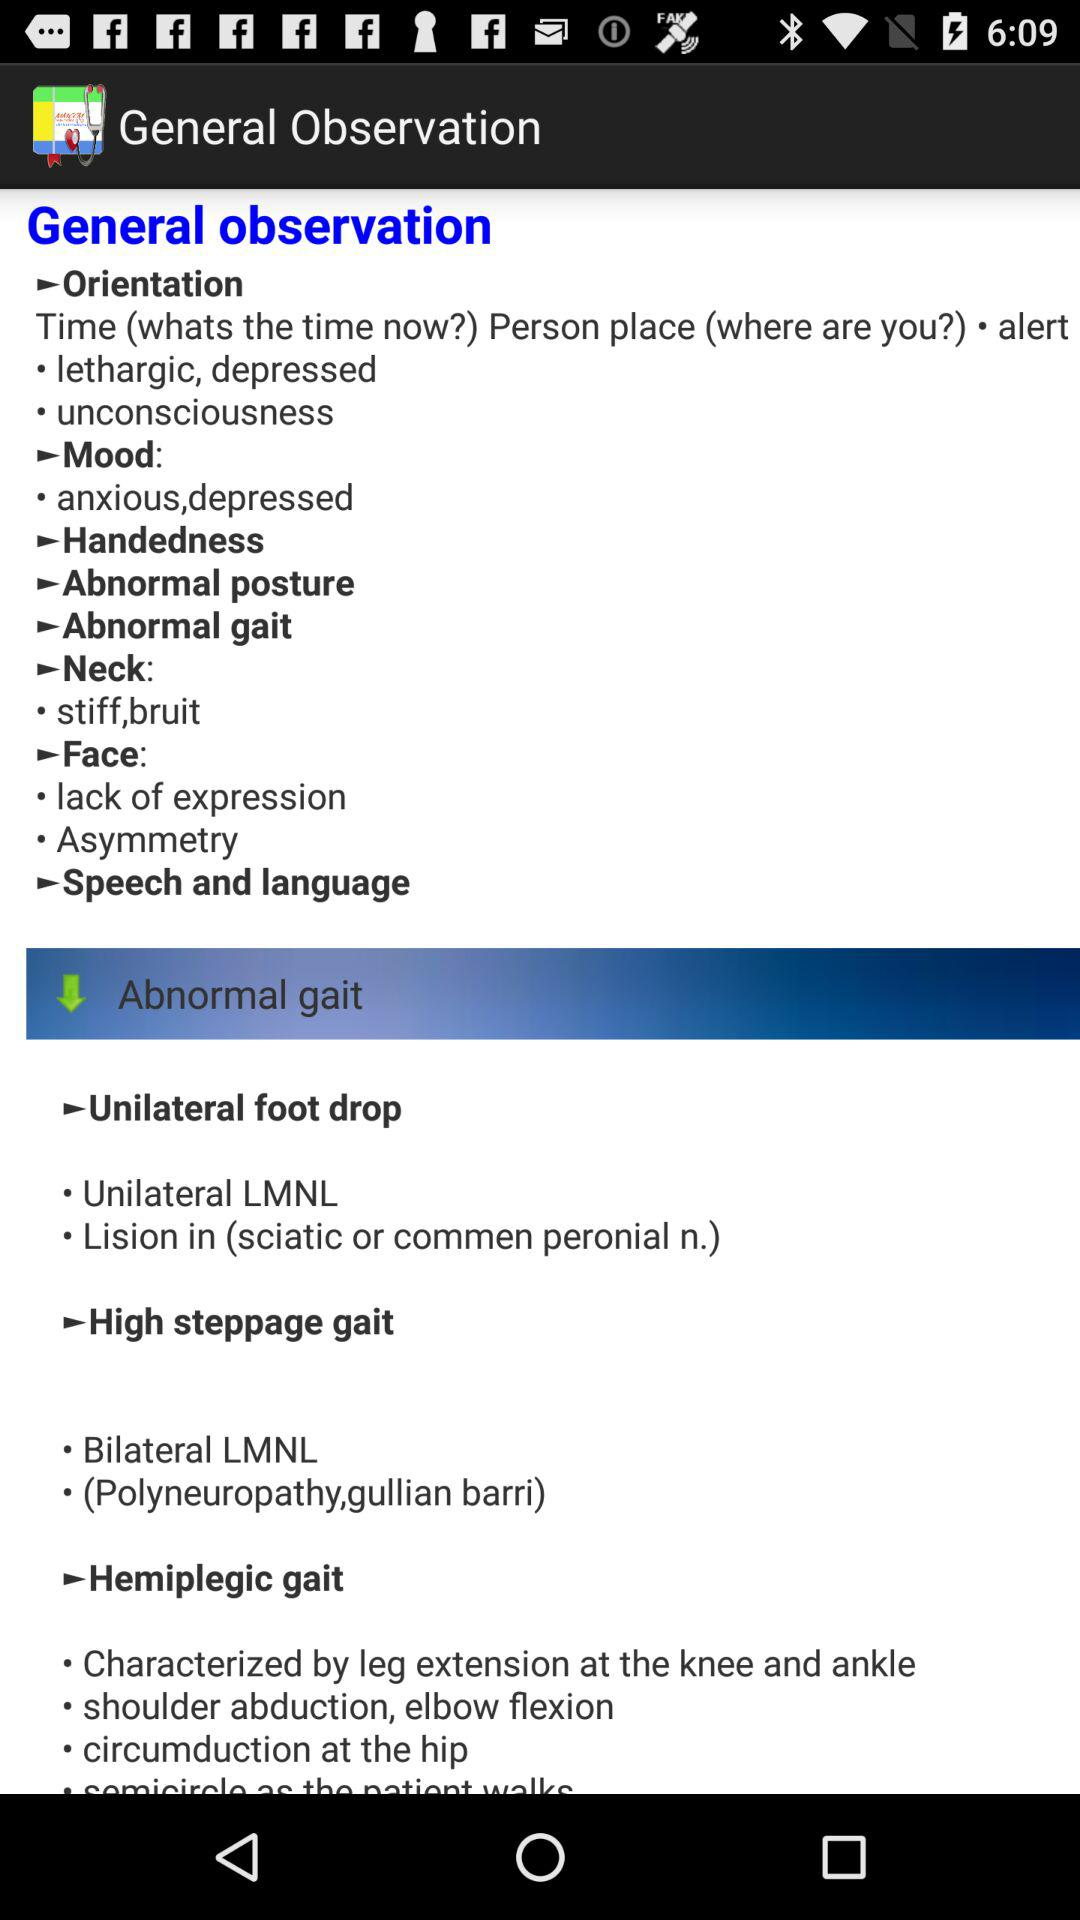What is the general observation under "Unilateral foot drop"? The general observations are "Unilateral LMNL" and "Lision in (sciatic or commen peronial n.)". 